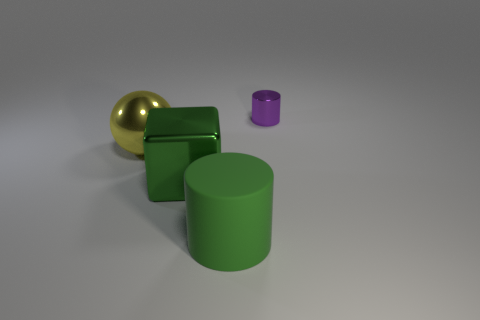What material is the block that is the same size as the sphere?
Make the answer very short. Metal. Is there another green object that has the same material as the small object?
Provide a succinct answer. Yes. How many small cyan matte blocks are there?
Provide a short and direct response. 0. Are the large cylinder and the object behind the yellow object made of the same material?
Offer a terse response. No. There is a block that is the same color as the matte cylinder; what is its material?
Give a very brief answer. Metal. How many matte cylinders are the same color as the small thing?
Offer a very short reply. 0. What size is the green shiny object?
Offer a terse response. Large. There is a large matte object; is it the same shape as the large shiny object that is to the right of the sphere?
Your answer should be compact. No. What color is the big object that is made of the same material as the sphere?
Provide a succinct answer. Green. There is a shiny thing that is to the right of the block; how big is it?
Provide a succinct answer. Small. 